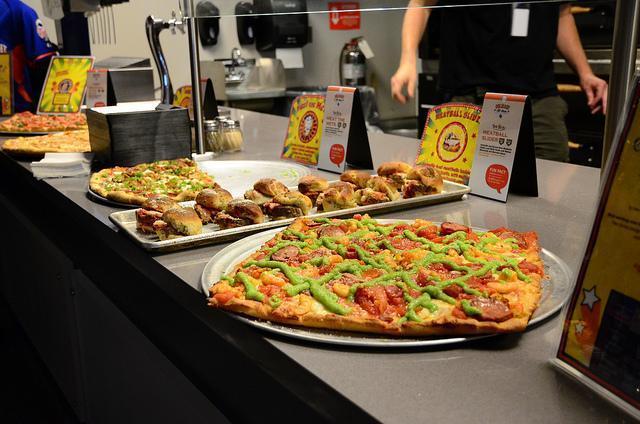How many pizzas?
Give a very brief answer. 4. How many pizzas can you see?
Give a very brief answer. 3. How many people are in the picture?
Give a very brief answer. 2. 